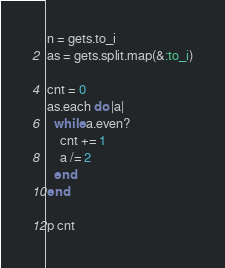<code> <loc_0><loc_0><loc_500><loc_500><_Ruby_>n = gets.to_i
as = gets.split.map(&:to_i)

cnt = 0
as.each do |a|
  while a.even?
    cnt += 1
    a /= 2
  end
end

p cnt
</code> 